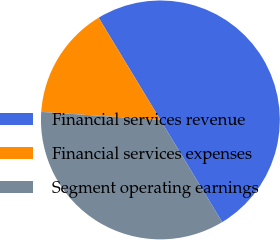<chart> <loc_0><loc_0><loc_500><loc_500><pie_chart><fcel>Financial services revenue<fcel>Financial services expenses<fcel>Segment operating earnings<nl><fcel>50.0%<fcel>15.28%<fcel>34.72%<nl></chart> 